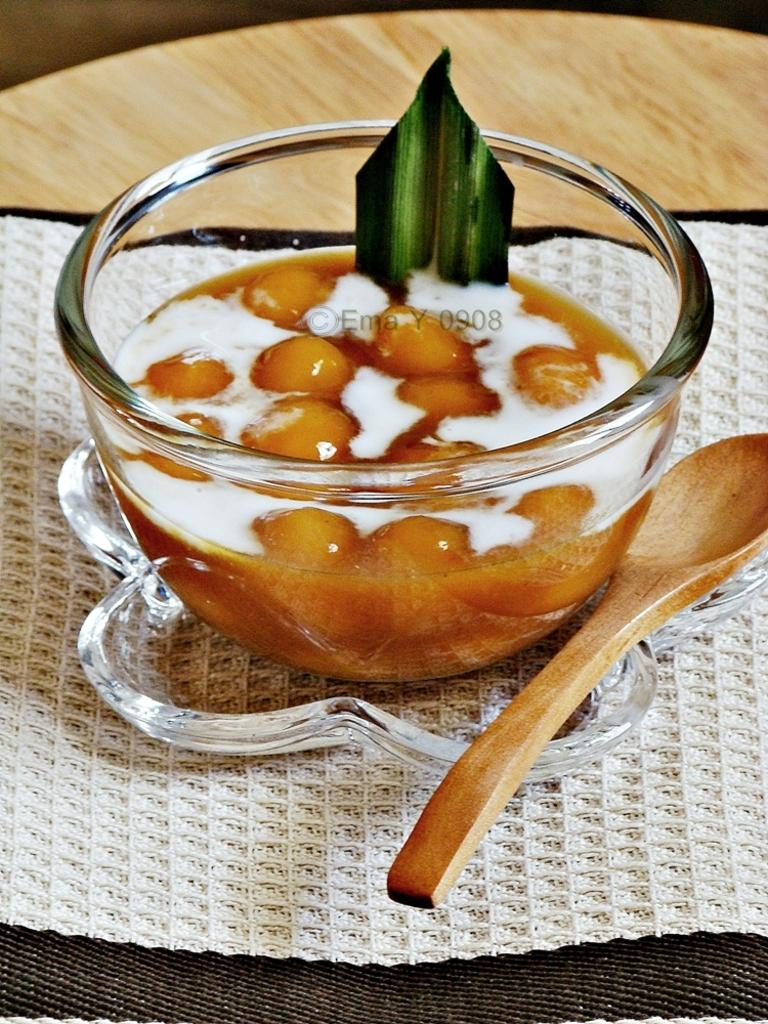What is in the bowl that is visible in the image? There is an edible placed in a bowl in the image. What utensil is located beside the bowl in the image? There is a wooden spoon beside the bowl in the image. How many horses are present in the image? There are no horses present in the image. What type of jam is being used to destroy the edible in the image? There is no jam or destruction present in the image; it features an edible in a bowl with a wooden spoon beside it. 